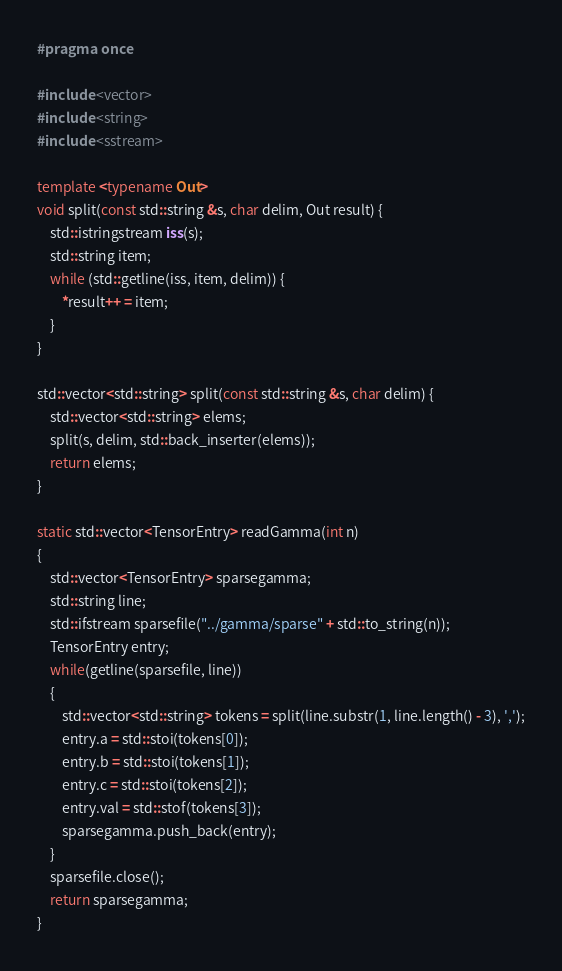<code> <loc_0><loc_0><loc_500><loc_500><_C++_>#pragma once

#include <vector>
#include <string>
#include <sstream>

template <typename Out>
void split(const std::string &s, char delim, Out result) {
    std::istringstream iss(s);
    std::string item;
    while (std::getline(iss, item, delim)) {
        *result++ = item;
    }
}

std::vector<std::string> split(const std::string &s, char delim) {
    std::vector<std::string> elems;
    split(s, delim, std::back_inserter(elems));
    return elems;
}

static std::vector<TensorEntry> readGamma(int n)
{
    std::vector<TensorEntry> sparsegamma;
    std::string line;
    std::ifstream sparsefile("../gamma/sparse" + std::to_string(n));
    TensorEntry entry;
    while(getline(sparsefile, line))
    {
        std::vector<std::string> tokens = split(line.substr(1, line.length() - 3), ',');
        entry.a = std::stoi(tokens[0]);
        entry.b = std::stoi(tokens[1]);
        entry.c = std::stoi(tokens[2]);
        entry.val = std::stof(tokens[3]);
        sparsegamma.push_back(entry);
    }
    sparsefile.close();
    return sparsegamma;
}</code> 